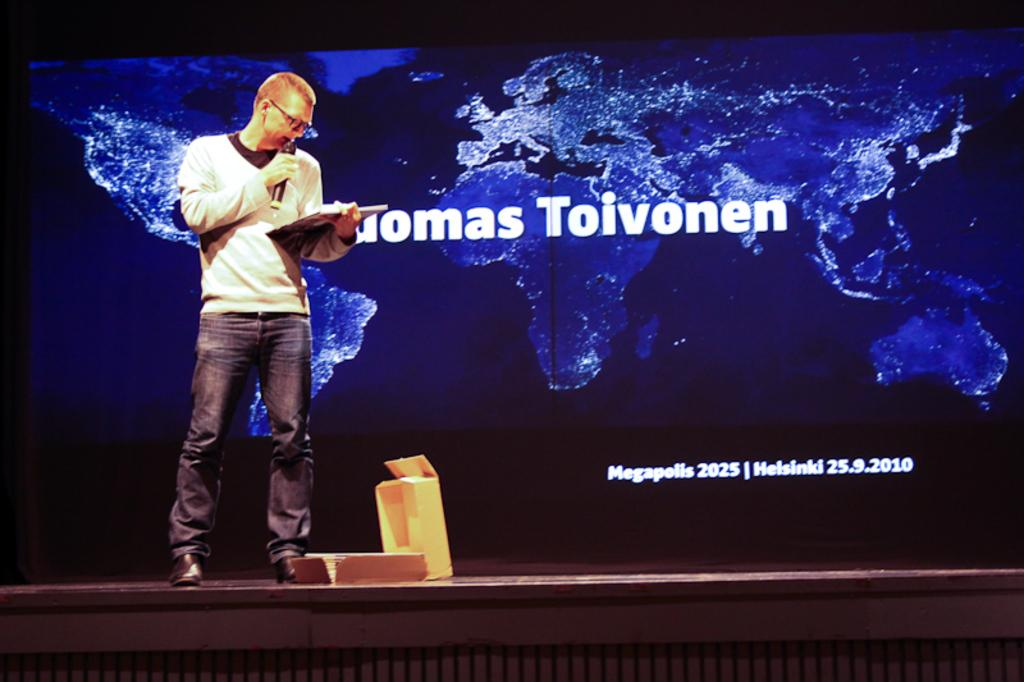Provide a one-sentence caption for the provided image. A man stands reading a book on a stage with a partially revelled name "..omas Toivonen" on a screen behind him and written below that is: "Megapolis 2025 Helsinki 25.9.2010". 